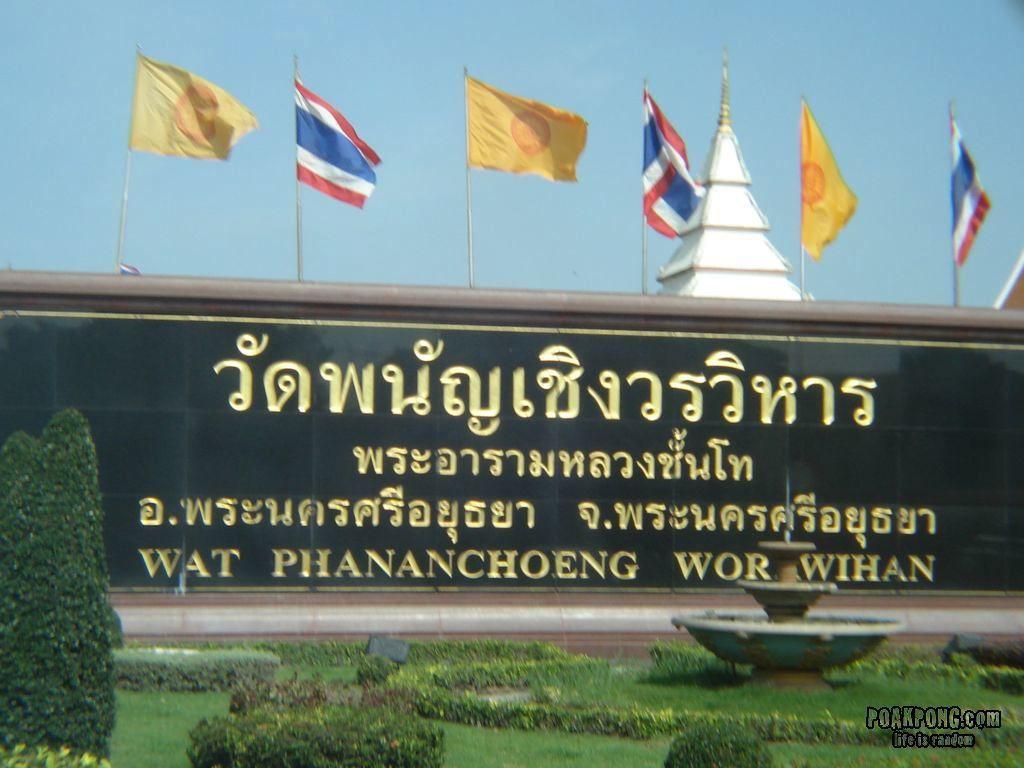Please provide a concise description of this image. In the front of the image there is a blackboard, flags, plants, grass, dome, water fountain and objects. In the background of the image there is blue sky. At the bottom right side of the image there is a watermark. Something is written on the blackboard. 